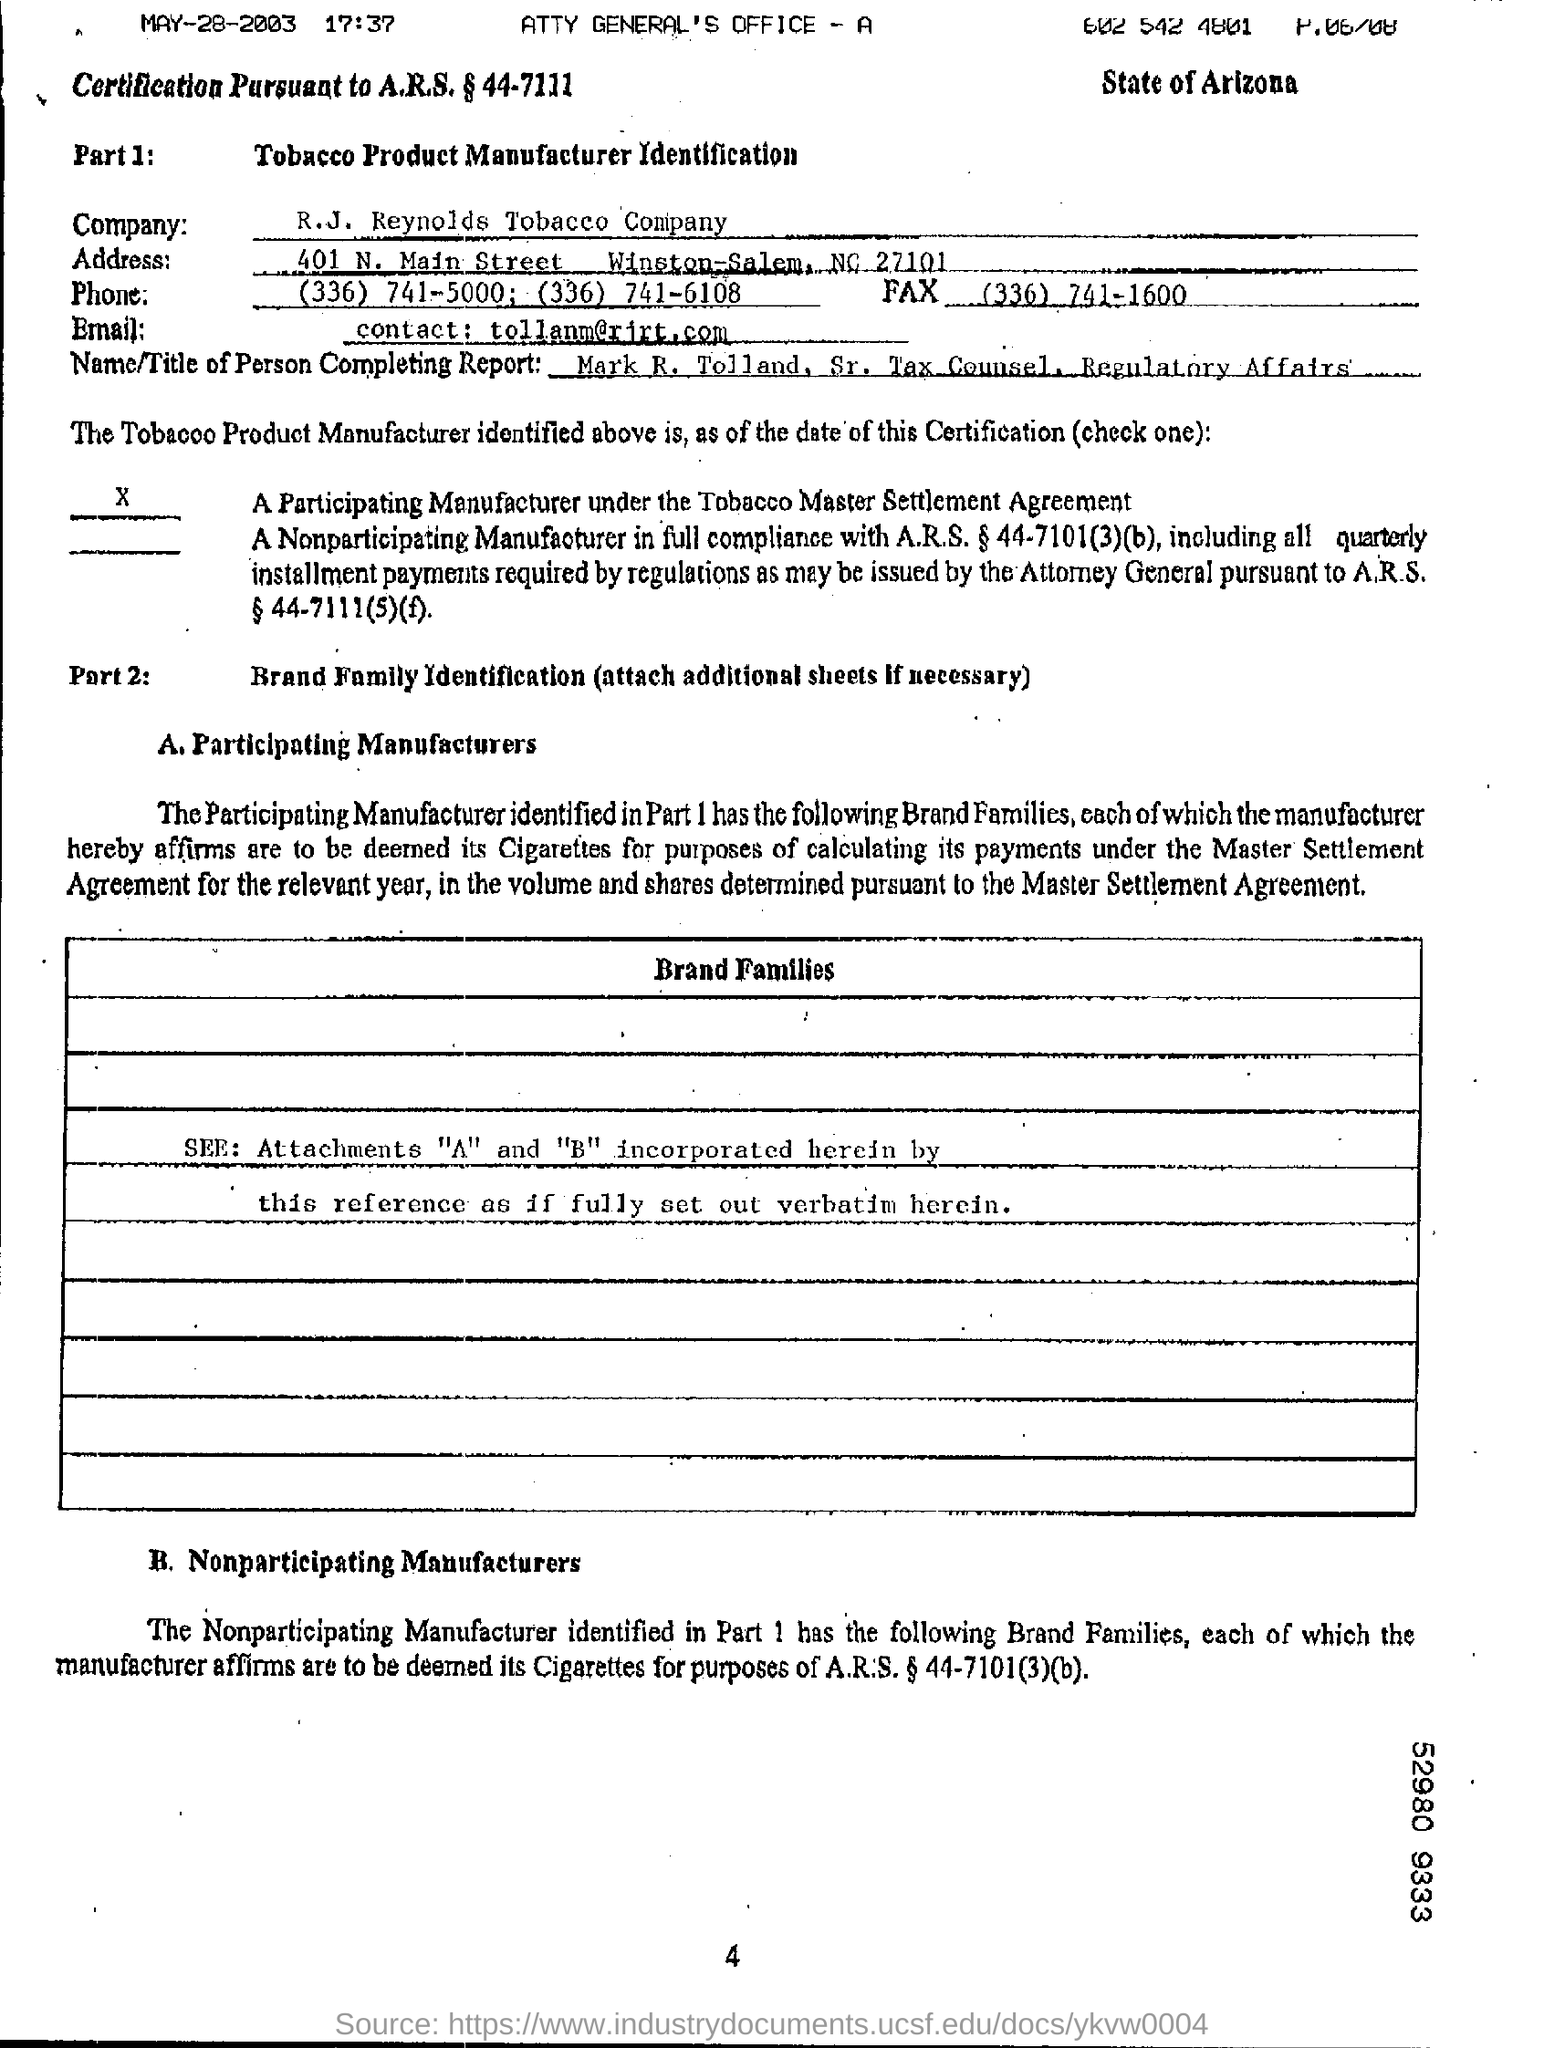What is the Company Name ?
Offer a terse response. R.J. Reynolds Tobacco Company. What is the Fax Number ?
Offer a very short reply. (336) 741-1600. What is the Date mentioned in the top left of the document ?
Your response must be concise. MAY-28-2003. 